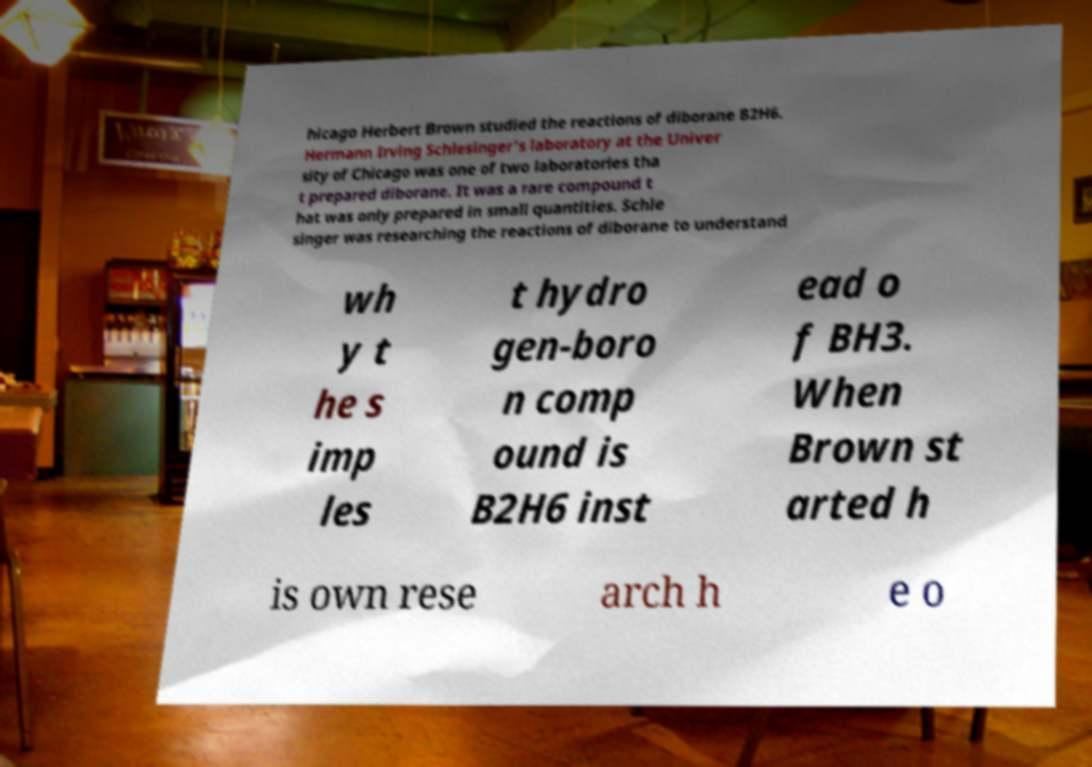Could you assist in decoding the text presented in this image and type it out clearly? hicago Herbert Brown studied the reactions of diborane B2H6. Hermann Irving Schlesinger's laboratory at the Univer sity of Chicago was one of two laboratories tha t prepared diborane. It was a rare compound t hat was only prepared in small quantities. Schle singer was researching the reactions of diborane to understand wh y t he s imp les t hydro gen-boro n comp ound is B2H6 inst ead o f BH3. When Brown st arted h is own rese arch h e o 